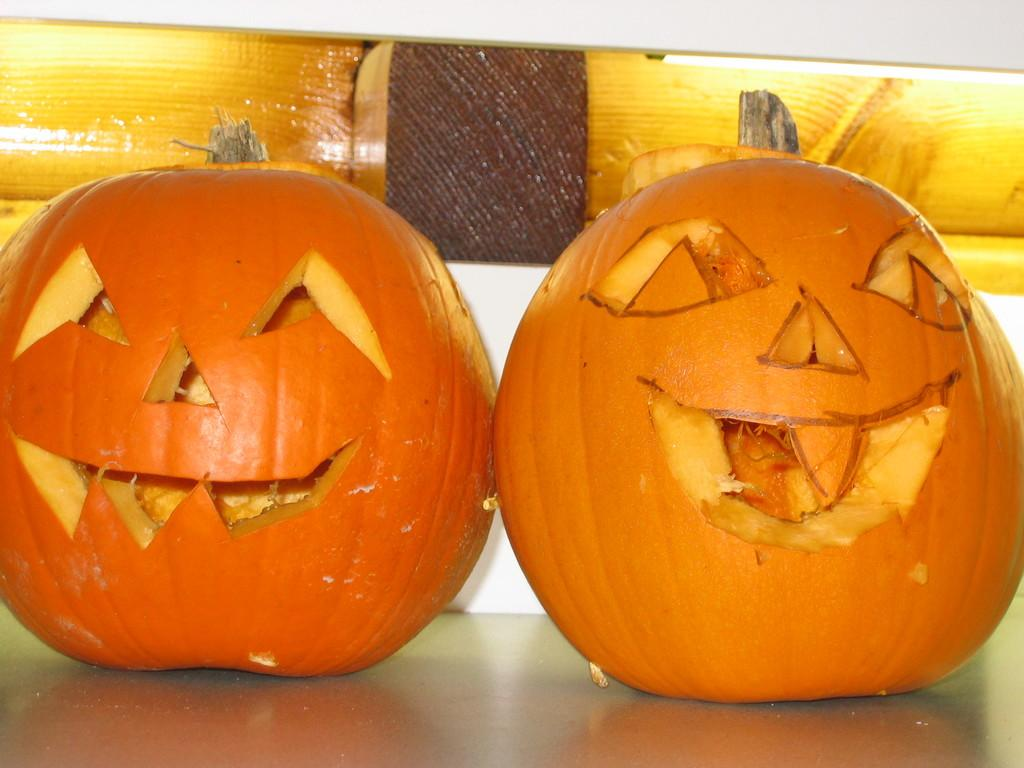What objects are featured in the image? There are carved pumpkins in the image. Where are the carved pumpkins located? The carved pumpkins are placed on a table. What type of stitch is used to decorate the doll in the image? There is no doll present in the image, so it is not possible to determine the type of stitch used for decoration. 